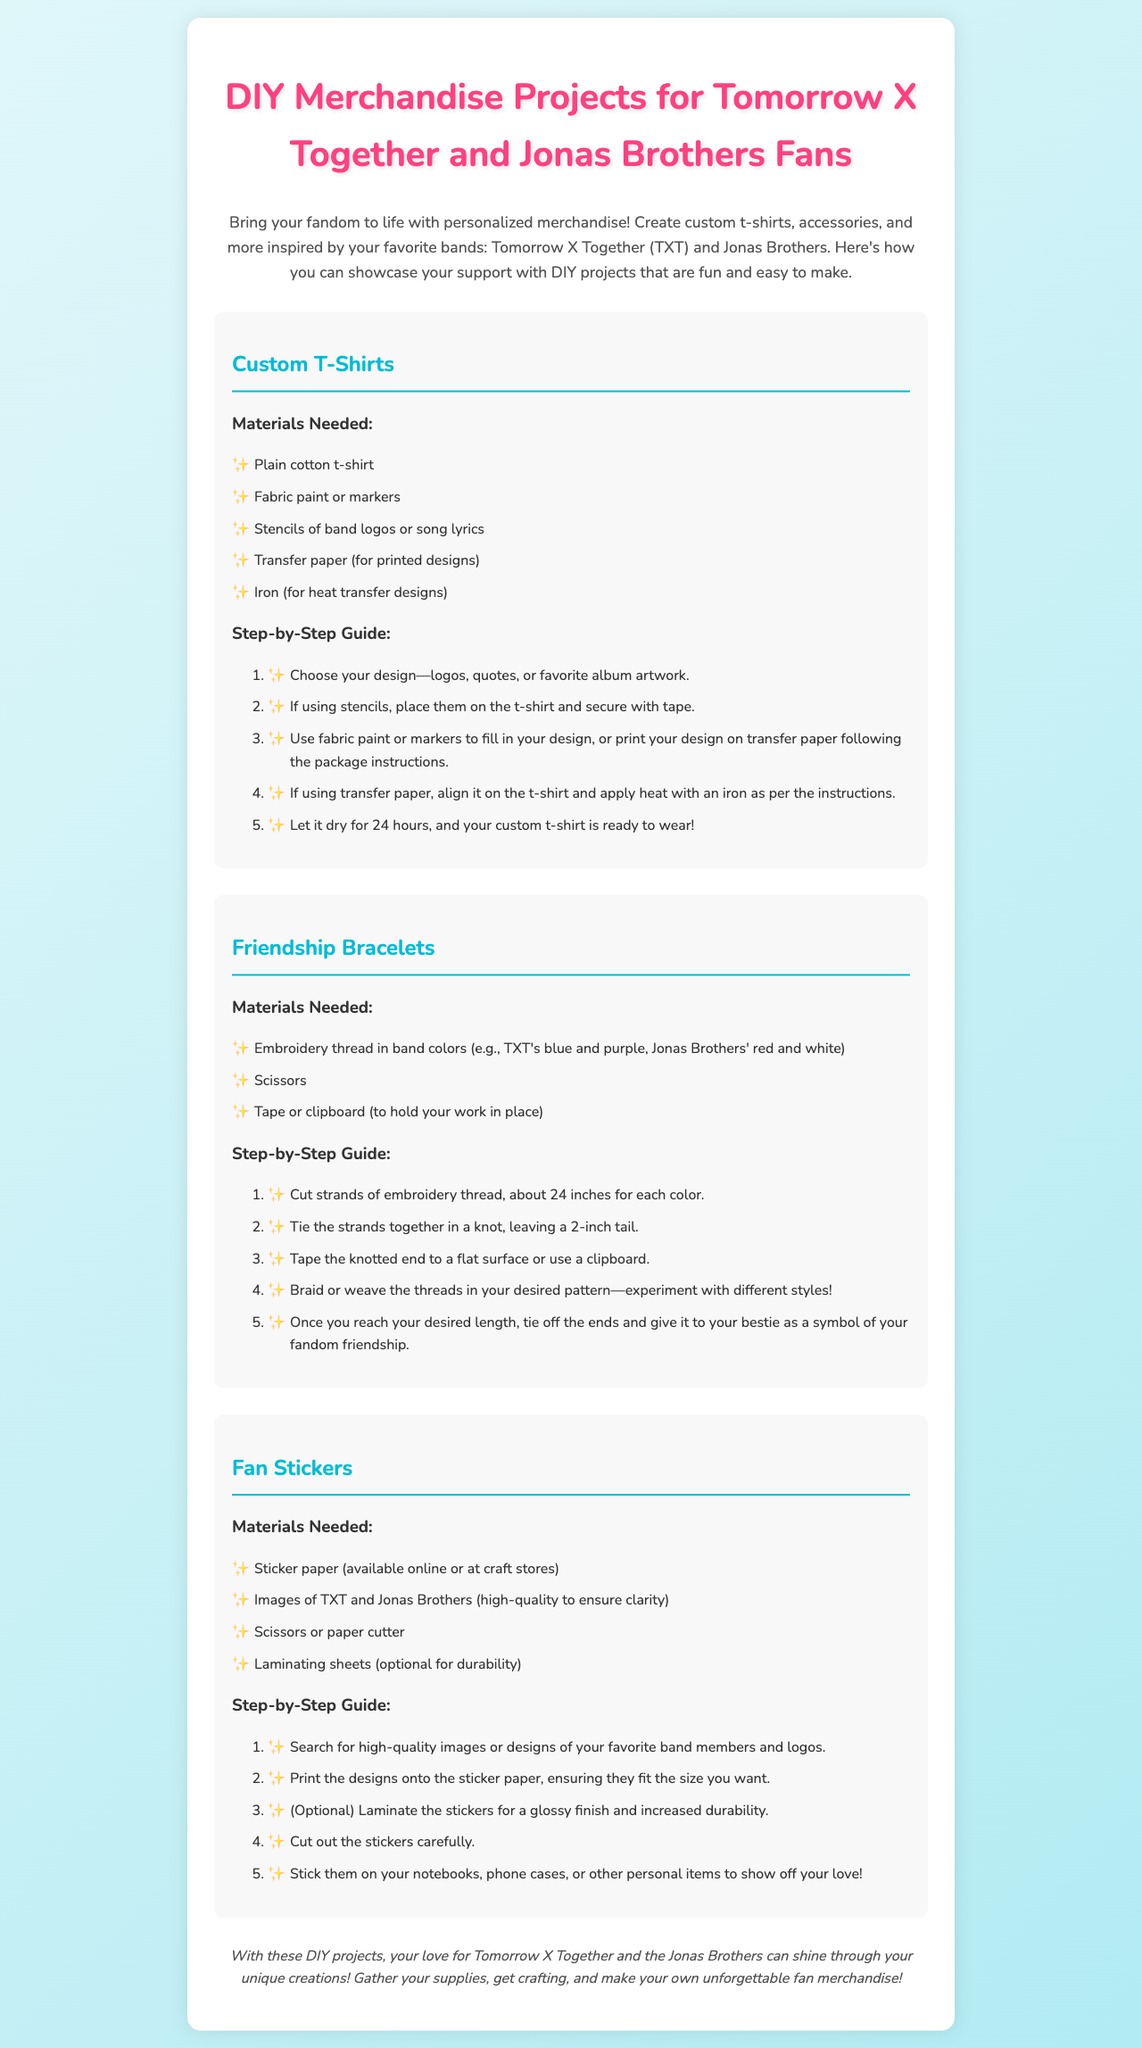What types of merchandise can you create? The document outlines how to create custom t-shirts, friendship bracelets, and fan stickers.
Answer: t-shirts, bracelets, stickers What is the first step in making custom t-shirts? The first step in the guide for custom t-shirts is to choose your design.
Answer: Choose your design How long should you let your custom t-shirt dry? The document states to let the custom t-shirt dry for 24 hours after finishing.
Answer: 24 hours What colors of embroidery thread are suggested for friendship bracelets? The document suggests using blue and purple for TXT and red and white for Jonas Brothers.
Answer: blue, purple, red, white What optional item can you use for stickers to increase durability? The document mentions using laminating sheets as an optional item for durability.
Answer: Laminating sheets How are the strands of embroidery thread prepared for friendship bracelets? The strands are cut to about 24 inches for each color before tying them together.
Answer: Cut to 24 inches What is used to hold the knotted ends of the embroidery threads in place? The document suggests using tape or a clipboard to hold the knotted ends during the bracelet-making process.
Answer: Tape or clipboard What design elements can be included in fan stickers? The design elements for fan stickers can include images of TXT and Jonas Brothers, such as members and logos.
Answer: Images of band members and logos 